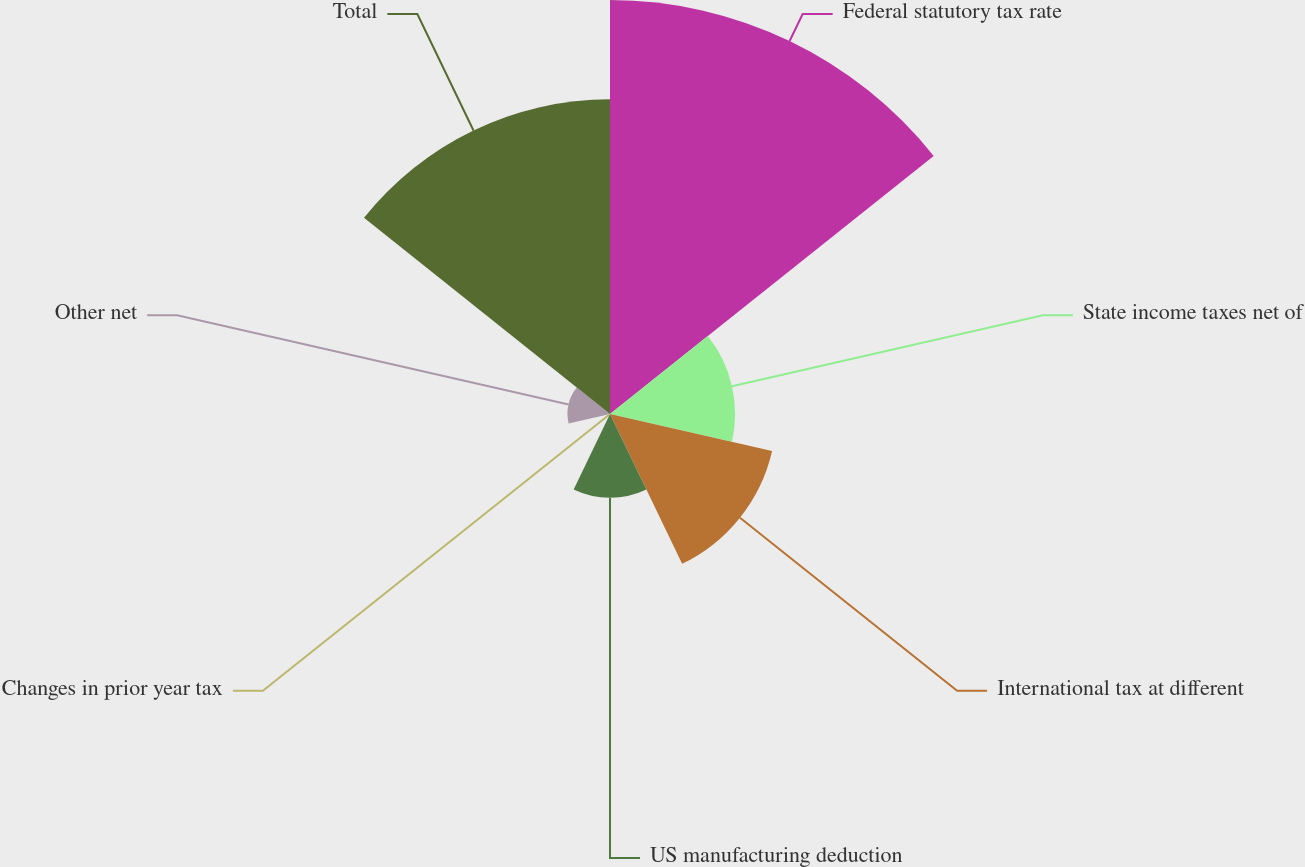Convert chart. <chart><loc_0><loc_0><loc_500><loc_500><pie_chart><fcel>Federal statutory tax rate<fcel>State income taxes net of<fcel>International tax at different<fcel>US manufacturing deduction<fcel>Changes in prior year tax<fcel>Other net<fcel>Total<nl><fcel>36.08%<fcel>10.9%<fcel>14.49%<fcel>7.3%<fcel>0.1%<fcel>3.7%<fcel>27.42%<nl></chart> 